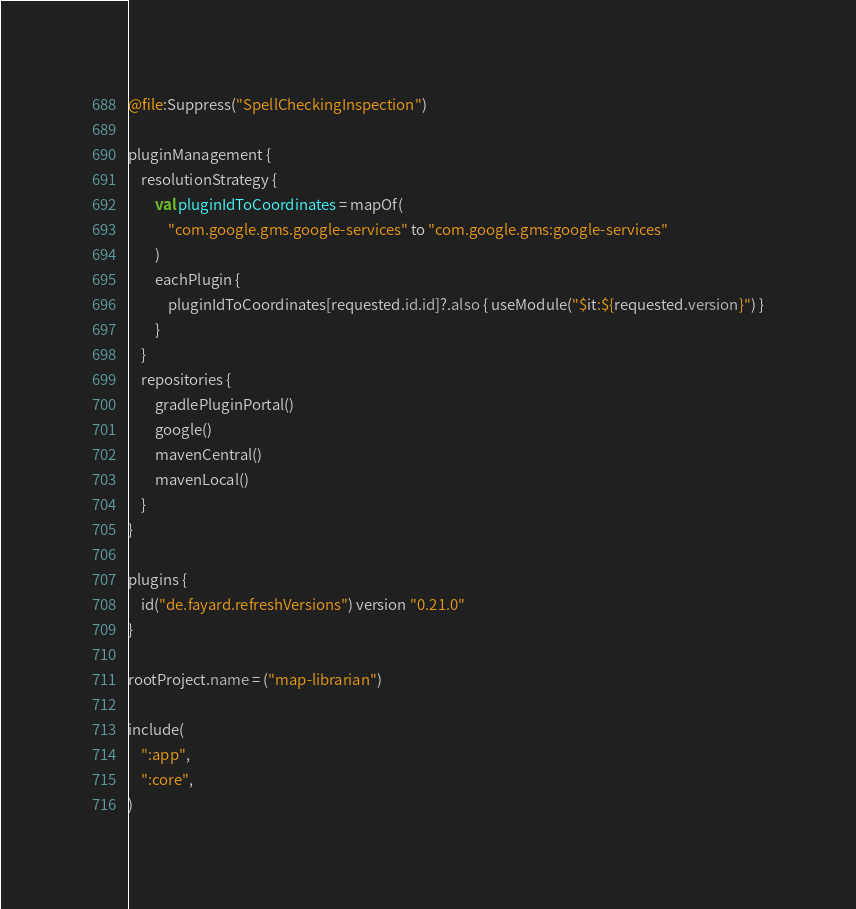<code> <loc_0><loc_0><loc_500><loc_500><_Kotlin_>@file:Suppress("SpellCheckingInspection")

pluginManagement {
    resolutionStrategy {
        val pluginIdToCoordinates = mapOf(
            "com.google.gms.google-services" to "com.google.gms:google-services"
        )
        eachPlugin {
            pluginIdToCoordinates[requested.id.id]?.also { useModule("$it:${requested.version}") }
        }
    }
    repositories {
        gradlePluginPortal()
        google()
        mavenCentral()
        mavenLocal()
    }
}

plugins {
    id("de.fayard.refreshVersions") version "0.21.0"
}

rootProject.name = ("map-librarian")

include(
    ":app",
    ":core",
)
</code> 